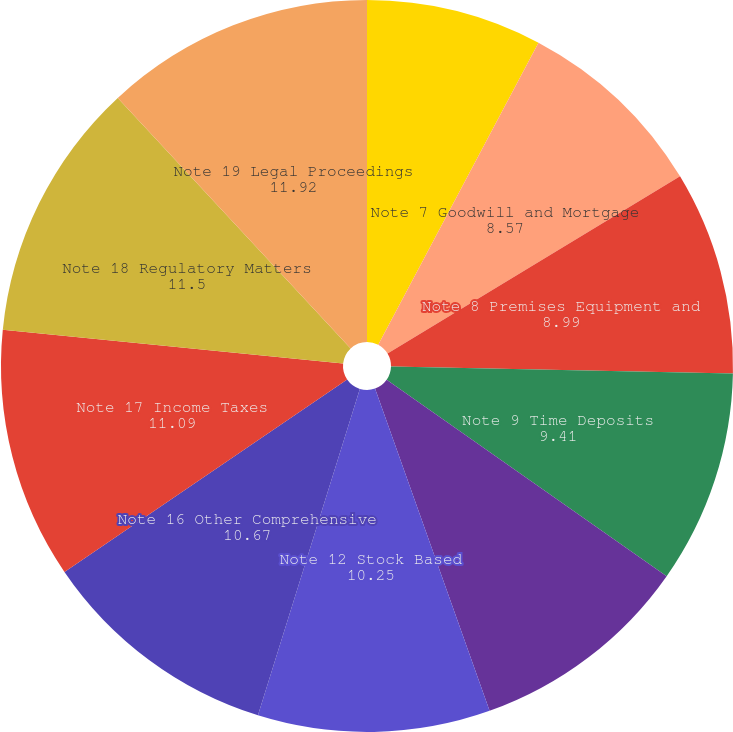Convert chart. <chart><loc_0><loc_0><loc_500><loc_500><pie_chart><fcel>Note 6 Fair Value<fcel>Note 7 Goodwill and Mortgage<fcel>Note 8 Premises Equipment and<fcel>Note 9 Time Deposits<fcel>Note 10 Borrowed Funds Note 11<fcel>Note 12 Stock Based<fcel>Note 16 Other Comprehensive<fcel>Note 17 Income Taxes<fcel>Note 18 Regulatory Matters<fcel>Note 19 Legal Proceedings<nl><fcel>7.76%<fcel>8.57%<fcel>8.99%<fcel>9.41%<fcel>9.83%<fcel>10.25%<fcel>10.67%<fcel>11.09%<fcel>11.5%<fcel>11.92%<nl></chart> 